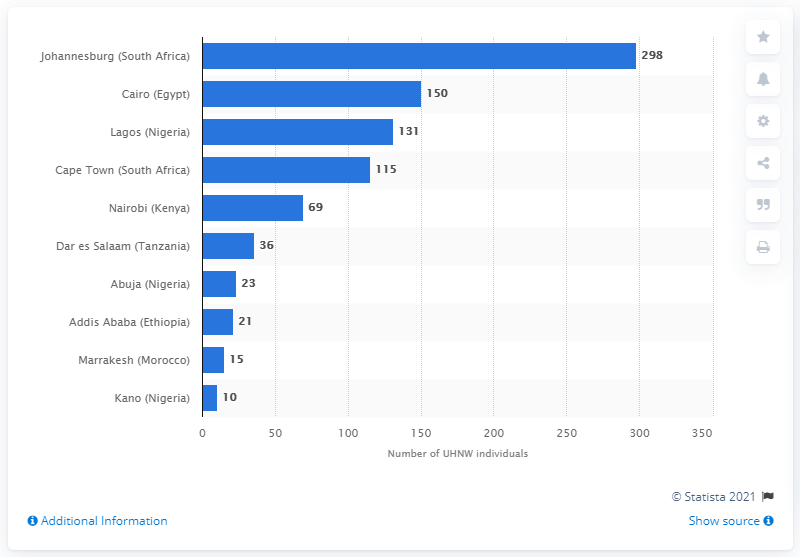Outline some significant characteristics in this image. In 2013, there were 298 ultra high wealth individuals living in Johannesburg. In 2013, it is reported that 10 African cities had the largest number of ultra high wealth individuals. 